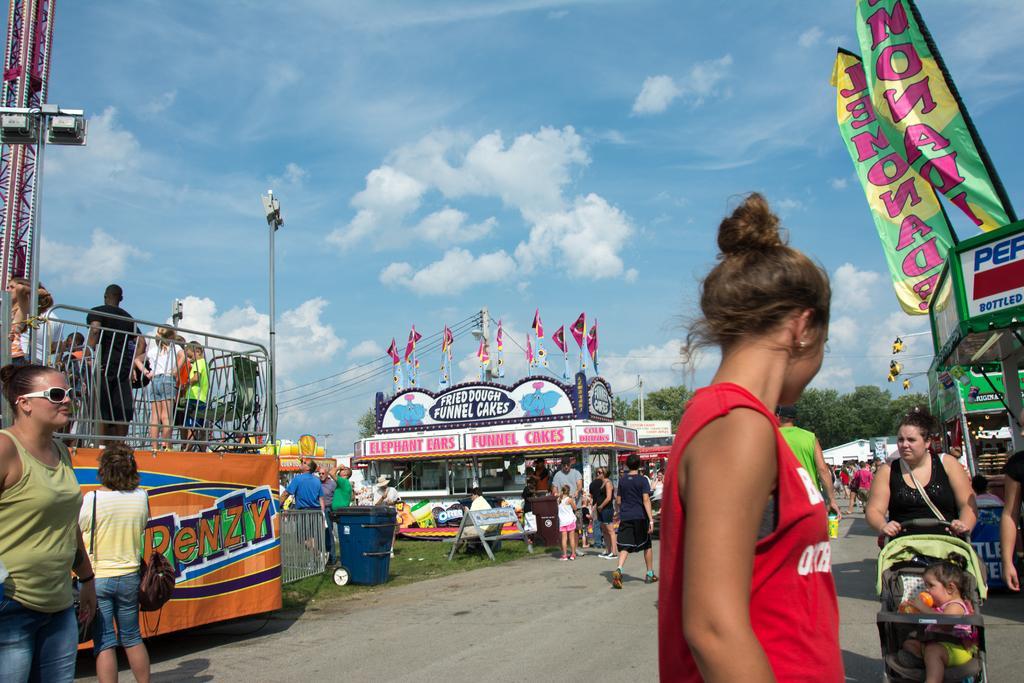Please provide a concise description of this image. In this image there are stalls. There are people walking. There are trees and grass. There are electric poles. There are clouds in the sky. 